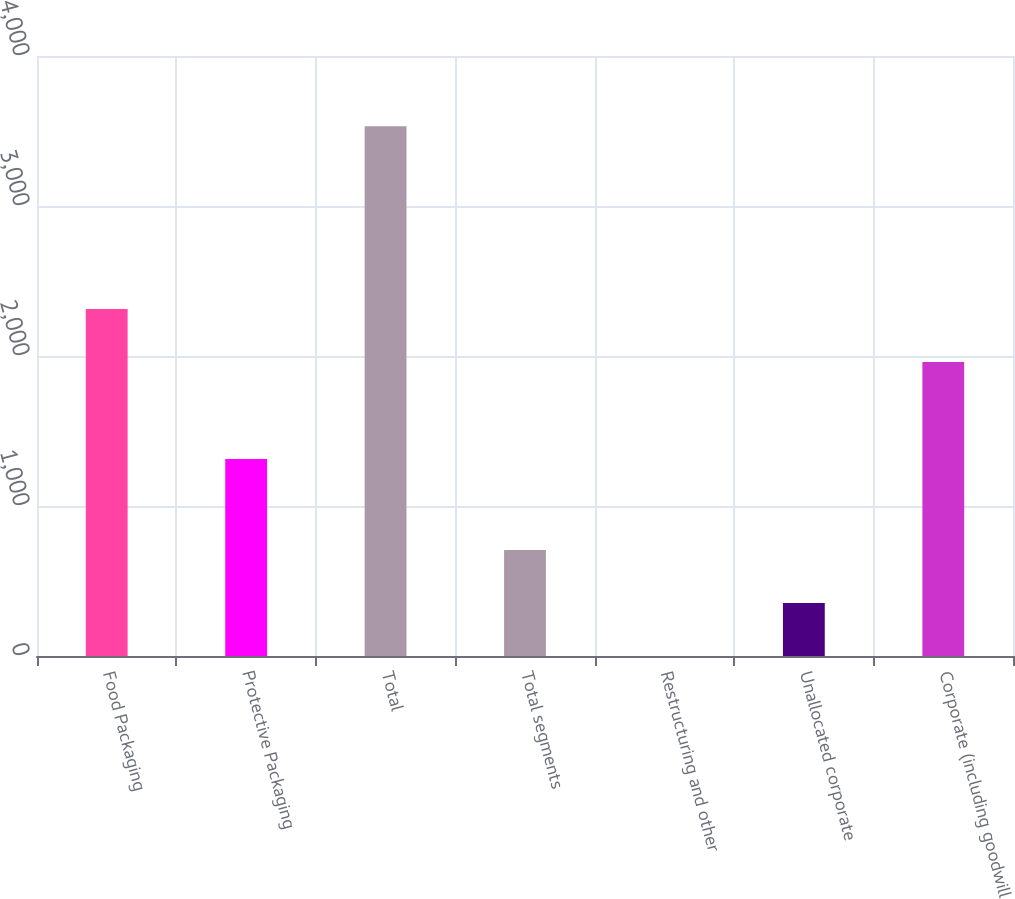Convert chart. <chart><loc_0><loc_0><loc_500><loc_500><bar_chart><fcel>Food Packaging<fcel>Protective Packaging<fcel>Total<fcel>Total segments<fcel>Restructuring and other<fcel>Unallocated corporate<fcel>Corporate (including goodwill<nl><fcel>2313.94<fcel>1313.3<fcel>3531.9<fcel>706.78<fcel>0.5<fcel>353.64<fcel>1960.8<nl></chart> 